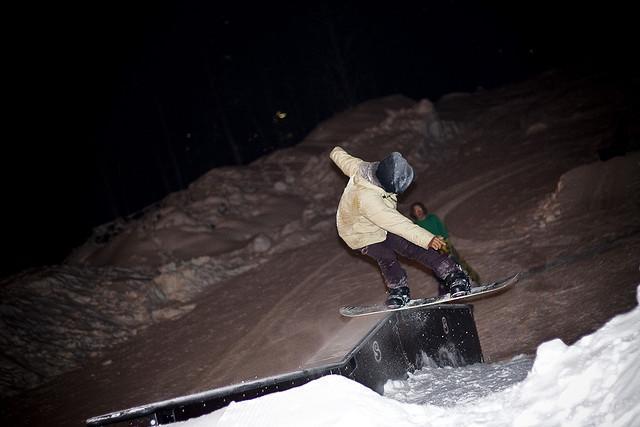How many colors are in the boy's shirt?
Give a very brief answer. 1. How many elephant are facing the right side of the image?
Give a very brief answer. 0. 